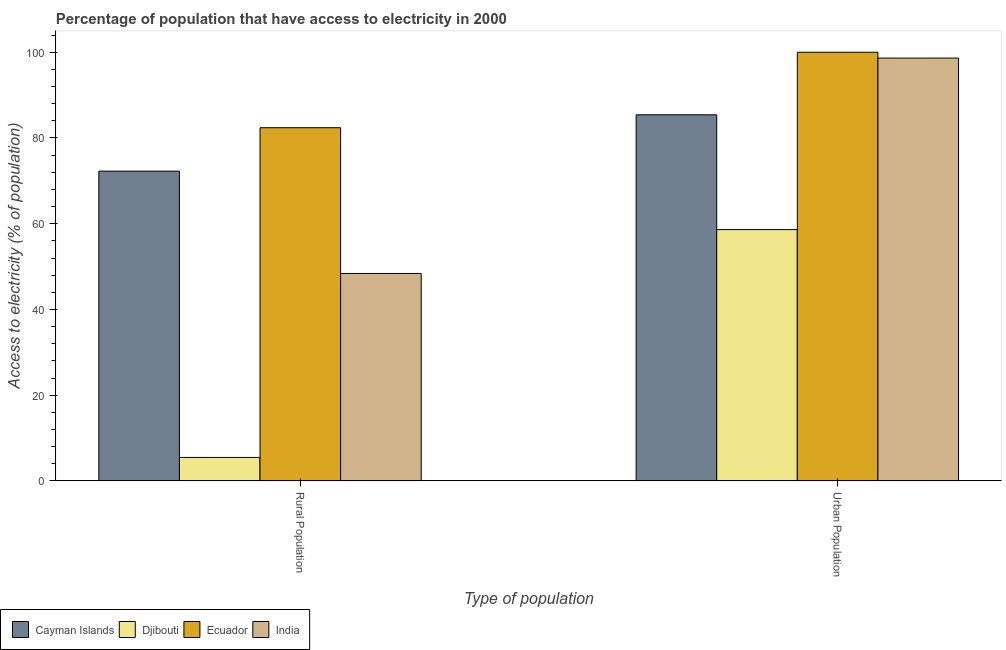How many different coloured bars are there?
Make the answer very short. 4. How many groups of bars are there?
Your answer should be compact. 2. How many bars are there on the 1st tick from the right?
Your answer should be very brief. 4. What is the label of the 1st group of bars from the left?
Keep it short and to the point. Rural Population. What is the percentage of urban population having access to electricity in Cayman Islands?
Offer a terse response. 85.41. Across all countries, what is the maximum percentage of urban population having access to electricity?
Your answer should be very brief. 100. Across all countries, what is the minimum percentage of urban population having access to electricity?
Your answer should be very brief. 58.63. In which country was the percentage of rural population having access to electricity maximum?
Provide a short and direct response. Ecuador. In which country was the percentage of urban population having access to electricity minimum?
Your response must be concise. Djibouti. What is the total percentage of urban population having access to electricity in the graph?
Ensure brevity in your answer.  342.68. What is the difference between the percentage of urban population having access to electricity in Djibouti and that in Ecuador?
Ensure brevity in your answer.  -41.37. What is the difference between the percentage of urban population having access to electricity in Djibouti and the percentage of rural population having access to electricity in Cayman Islands?
Give a very brief answer. -13.64. What is the average percentage of urban population having access to electricity per country?
Provide a short and direct response. 85.67. What is the difference between the percentage of urban population having access to electricity and percentage of rural population having access to electricity in Ecuador?
Your answer should be very brief. 17.6. What is the ratio of the percentage of urban population having access to electricity in Ecuador to that in India?
Offer a very short reply. 1.01. In how many countries, is the percentage of rural population having access to electricity greater than the average percentage of rural population having access to electricity taken over all countries?
Your response must be concise. 2. What does the 4th bar from the left in Rural Population represents?
Your response must be concise. India. What does the 4th bar from the right in Urban Population represents?
Provide a short and direct response. Cayman Islands. How many bars are there?
Your response must be concise. 8. Does the graph contain any zero values?
Provide a succinct answer. No. What is the title of the graph?
Provide a short and direct response. Percentage of population that have access to electricity in 2000. Does "Norway" appear as one of the legend labels in the graph?
Ensure brevity in your answer.  No. What is the label or title of the X-axis?
Provide a succinct answer. Type of population. What is the label or title of the Y-axis?
Provide a short and direct response. Access to electricity (% of population). What is the Access to electricity (% of population) of Cayman Islands in Rural Population?
Make the answer very short. 72.27. What is the Access to electricity (% of population) in Djibouti in Rural Population?
Your answer should be very brief. 5.48. What is the Access to electricity (% of population) in Ecuador in Rural Population?
Your response must be concise. 82.4. What is the Access to electricity (% of population) in India in Rural Population?
Make the answer very short. 48.4. What is the Access to electricity (% of population) in Cayman Islands in Urban Population?
Provide a short and direct response. 85.41. What is the Access to electricity (% of population) in Djibouti in Urban Population?
Give a very brief answer. 58.63. What is the Access to electricity (% of population) in India in Urban Population?
Your answer should be very brief. 98.64. Across all Type of population, what is the maximum Access to electricity (% of population) of Cayman Islands?
Give a very brief answer. 85.41. Across all Type of population, what is the maximum Access to electricity (% of population) in Djibouti?
Keep it short and to the point. 58.63. Across all Type of population, what is the maximum Access to electricity (% of population) of Ecuador?
Give a very brief answer. 100. Across all Type of population, what is the maximum Access to electricity (% of population) in India?
Your response must be concise. 98.64. Across all Type of population, what is the minimum Access to electricity (% of population) in Cayman Islands?
Keep it short and to the point. 72.27. Across all Type of population, what is the minimum Access to electricity (% of population) in Djibouti?
Offer a terse response. 5.48. Across all Type of population, what is the minimum Access to electricity (% of population) in Ecuador?
Offer a very short reply. 82.4. Across all Type of population, what is the minimum Access to electricity (% of population) in India?
Make the answer very short. 48.4. What is the total Access to electricity (% of population) of Cayman Islands in the graph?
Offer a terse response. 157.68. What is the total Access to electricity (% of population) of Djibouti in the graph?
Make the answer very short. 64.11. What is the total Access to electricity (% of population) in Ecuador in the graph?
Provide a succinct answer. 182.4. What is the total Access to electricity (% of population) of India in the graph?
Offer a very short reply. 147.04. What is the difference between the Access to electricity (% of population) in Cayman Islands in Rural Population and that in Urban Population?
Keep it short and to the point. -13.15. What is the difference between the Access to electricity (% of population) in Djibouti in Rural Population and that in Urban Population?
Your answer should be very brief. -53.15. What is the difference between the Access to electricity (% of population) of Ecuador in Rural Population and that in Urban Population?
Your answer should be very brief. -17.6. What is the difference between the Access to electricity (% of population) in India in Rural Population and that in Urban Population?
Make the answer very short. -50.24. What is the difference between the Access to electricity (% of population) of Cayman Islands in Rural Population and the Access to electricity (% of population) of Djibouti in Urban Population?
Provide a short and direct response. 13.64. What is the difference between the Access to electricity (% of population) of Cayman Islands in Rural Population and the Access to electricity (% of population) of Ecuador in Urban Population?
Provide a succinct answer. -27.73. What is the difference between the Access to electricity (% of population) of Cayman Islands in Rural Population and the Access to electricity (% of population) of India in Urban Population?
Your answer should be compact. -26.38. What is the difference between the Access to electricity (% of population) of Djibouti in Rural Population and the Access to electricity (% of population) of Ecuador in Urban Population?
Your response must be concise. -94.52. What is the difference between the Access to electricity (% of population) in Djibouti in Rural Population and the Access to electricity (% of population) in India in Urban Population?
Offer a terse response. -93.16. What is the difference between the Access to electricity (% of population) in Ecuador in Rural Population and the Access to electricity (% of population) in India in Urban Population?
Offer a very short reply. -16.24. What is the average Access to electricity (% of population) in Cayman Islands per Type of population?
Provide a succinct answer. 78.84. What is the average Access to electricity (% of population) of Djibouti per Type of population?
Your answer should be very brief. 32.05. What is the average Access to electricity (% of population) of Ecuador per Type of population?
Offer a very short reply. 91.2. What is the average Access to electricity (% of population) in India per Type of population?
Your answer should be very brief. 73.52. What is the difference between the Access to electricity (% of population) of Cayman Islands and Access to electricity (% of population) of Djibouti in Rural Population?
Provide a succinct answer. 66.78. What is the difference between the Access to electricity (% of population) in Cayman Islands and Access to electricity (% of population) in Ecuador in Rural Population?
Offer a terse response. -10.13. What is the difference between the Access to electricity (% of population) in Cayman Islands and Access to electricity (% of population) in India in Rural Population?
Your answer should be compact. 23.86. What is the difference between the Access to electricity (% of population) in Djibouti and Access to electricity (% of population) in Ecuador in Rural Population?
Provide a succinct answer. -76.92. What is the difference between the Access to electricity (% of population) of Djibouti and Access to electricity (% of population) of India in Rural Population?
Ensure brevity in your answer.  -42.92. What is the difference between the Access to electricity (% of population) in Cayman Islands and Access to electricity (% of population) in Djibouti in Urban Population?
Ensure brevity in your answer.  26.78. What is the difference between the Access to electricity (% of population) of Cayman Islands and Access to electricity (% of population) of Ecuador in Urban Population?
Give a very brief answer. -14.59. What is the difference between the Access to electricity (% of population) of Cayman Islands and Access to electricity (% of population) of India in Urban Population?
Give a very brief answer. -13.23. What is the difference between the Access to electricity (% of population) of Djibouti and Access to electricity (% of population) of Ecuador in Urban Population?
Ensure brevity in your answer.  -41.37. What is the difference between the Access to electricity (% of population) in Djibouti and Access to electricity (% of population) in India in Urban Population?
Ensure brevity in your answer.  -40.01. What is the difference between the Access to electricity (% of population) of Ecuador and Access to electricity (% of population) of India in Urban Population?
Your response must be concise. 1.36. What is the ratio of the Access to electricity (% of population) of Cayman Islands in Rural Population to that in Urban Population?
Provide a succinct answer. 0.85. What is the ratio of the Access to electricity (% of population) in Djibouti in Rural Population to that in Urban Population?
Ensure brevity in your answer.  0.09. What is the ratio of the Access to electricity (% of population) of Ecuador in Rural Population to that in Urban Population?
Ensure brevity in your answer.  0.82. What is the ratio of the Access to electricity (% of population) in India in Rural Population to that in Urban Population?
Offer a very short reply. 0.49. What is the difference between the highest and the second highest Access to electricity (% of population) in Cayman Islands?
Your answer should be very brief. 13.15. What is the difference between the highest and the second highest Access to electricity (% of population) of Djibouti?
Your response must be concise. 53.15. What is the difference between the highest and the second highest Access to electricity (% of population) in India?
Keep it short and to the point. 50.24. What is the difference between the highest and the lowest Access to electricity (% of population) of Cayman Islands?
Offer a terse response. 13.15. What is the difference between the highest and the lowest Access to electricity (% of population) in Djibouti?
Give a very brief answer. 53.15. What is the difference between the highest and the lowest Access to electricity (% of population) in India?
Give a very brief answer. 50.24. 